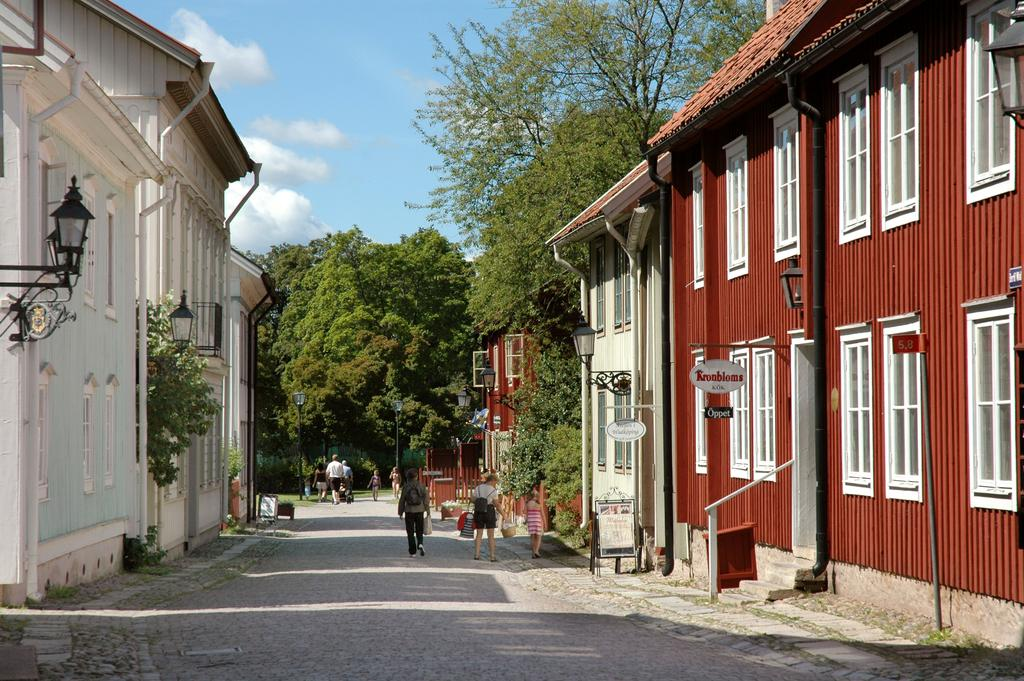What type of structures can be seen in the image? There are buildings in the image. What feature of the buildings is visible in the image? Windows are visible in the image. What are some other objects present in the image? Light-poles and signboards are visible in the image. What type of natural elements can be seen in the image? Trees are present in the image. What are the people in the image doing? The people in the image are wearing bags and walking on the road. What is the color of the sky in the image? The sky is blue and white in color. How many dimes are scattered on the ground in the image? There are no dimes present in the image. What type of creature is laying eggs on the light-pole in the image? There are no creatures or eggs present on the light-pole in the image. 